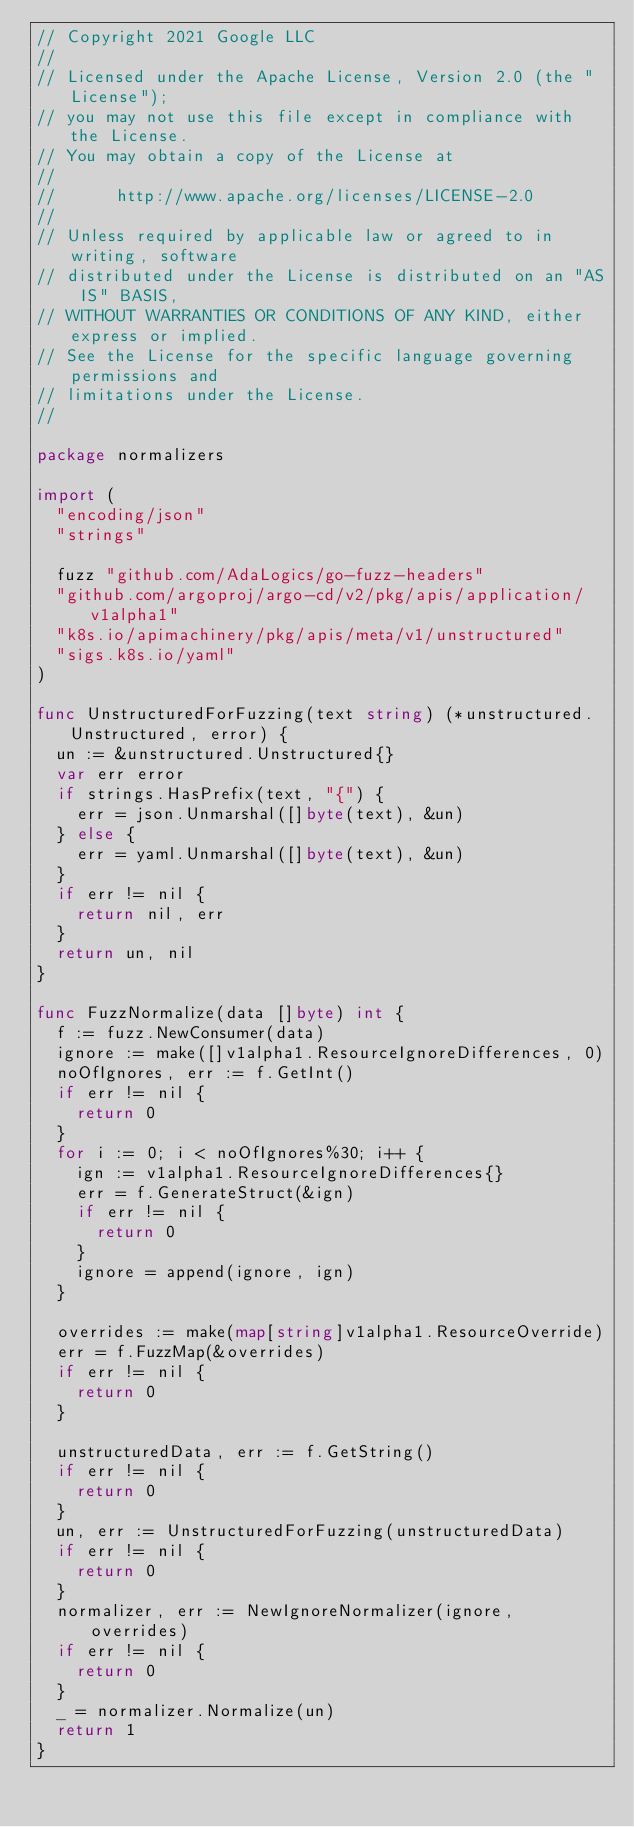Convert code to text. <code><loc_0><loc_0><loc_500><loc_500><_Go_>// Copyright 2021 Google LLC
//
// Licensed under the Apache License, Version 2.0 (the "License");
// you may not use this file except in compliance with the License.
// You may obtain a copy of the License at
//
//      http://www.apache.org/licenses/LICENSE-2.0
//
// Unless required by applicable law or agreed to in writing, software
// distributed under the License is distributed on an "AS IS" BASIS,
// WITHOUT WARRANTIES OR CONDITIONS OF ANY KIND, either express or implied.
// See the License for the specific language governing permissions and
// limitations under the License.
//

package normalizers

import (
	"encoding/json"
	"strings"

	fuzz "github.com/AdaLogics/go-fuzz-headers"
	"github.com/argoproj/argo-cd/v2/pkg/apis/application/v1alpha1"
	"k8s.io/apimachinery/pkg/apis/meta/v1/unstructured"
	"sigs.k8s.io/yaml"
)

func UnstructuredForFuzzing(text string) (*unstructured.Unstructured, error) {
	un := &unstructured.Unstructured{}
	var err error
	if strings.HasPrefix(text, "{") {
		err = json.Unmarshal([]byte(text), &un)
	} else {
		err = yaml.Unmarshal([]byte(text), &un)
	}
	if err != nil {
		return nil, err
	}
	return un, nil
}

func FuzzNormalize(data []byte) int {
	f := fuzz.NewConsumer(data)
	ignore := make([]v1alpha1.ResourceIgnoreDifferences, 0)
	noOfIgnores, err := f.GetInt()
	if err != nil {
		return 0
	}
	for i := 0; i < noOfIgnores%30; i++ {
		ign := v1alpha1.ResourceIgnoreDifferences{}
		err = f.GenerateStruct(&ign)
		if err != nil {
			return 0
		}
		ignore = append(ignore, ign)
	}

	overrides := make(map[string]v1alpha1.ResourceOverride)
	err = f.FuzzMap(&overrides)
	if err != nil {
		return 0
	}

	unstructuredData, err := f.GetString()
	if err != nil {
		return 0
	}
	un, err := UnstructuredForFuzzing(unstructuredData)
	if err != nil {
		return 0
	}
	normalizer, err := NewIgnoreNormalizer(ignore, overrides)
	if err != nil {
		return 0
	}
	_ = normalizer.Normalize(un)
	return 1
}
</code> 